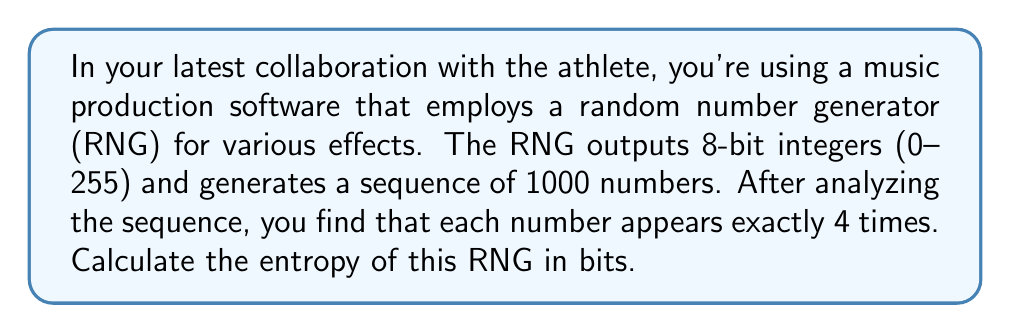Could you help me with this problem? Let's approach this step-by-step:

1) Entropy is a measure of randomness or unpredictability in a system. For a discrete random variable, it's calculated using the formula:

   $$ H = -\sum_{i=1}^{n} p(x_i) \log_2(p(x_i)) $$

   where $p(x_i)$ is the probability of outcome $x_i$.

2) In this case, we have 256 possible outcomes (8-bit integers from 0 to 255), and each outcome appears exactly 4 times in a sequence of 1000 numbers.

3) The probability of each outcome is:

   $$ p(x_i) = \frac{4}{1000} = \frac{1}{250} $$

4) Since all outcomes have the same probability, we can simplify our entropy calculation:

   $$ H = -256 \cdot \frac{1}{250} \log_2(\frac{1}{250}) $$

5) Simplify:
   
   $$ H = -\frac{256}{250} \log_2(\frac{1}{250}) $$

6) $\log_2(\frac{1}{250}) = -\log_2(250)$, so:

   $$ H = \frac{256}{250} \log_2(250) $$

7) Calculate:
   
   $$ H \approx 1.02399 \cdot 7.96578 \approx 8.15741 $$

Therefore, the entropy of this RNG is approximately 8.16 bits.
Answer: 8.16 bits 